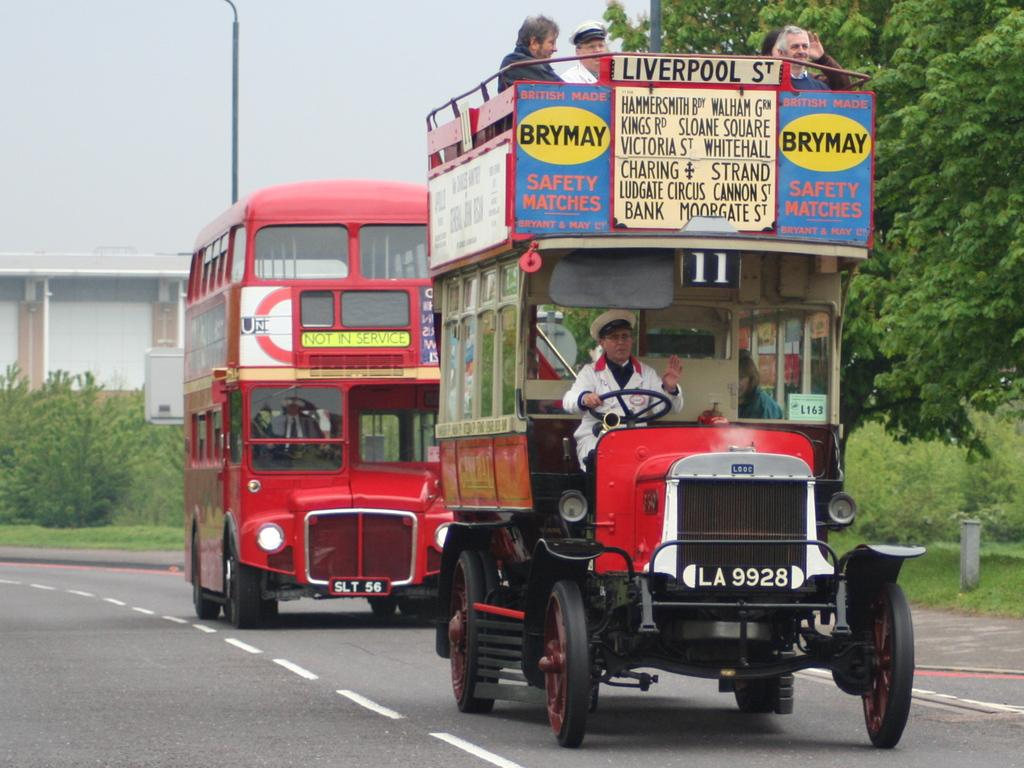What type of transportation can be seen in the image? There are motor vehicles in the image. Who is using the motor vehicles? People are traveling in the motor vehicles. What is the setting of the image? There is a road in the image, along with bushes, trees, poles, buildings, and the sky. What color is the eye of the person driving the car in the image? There is no eye visible in the image, as it is not possible to see inside the motor vehicles. 